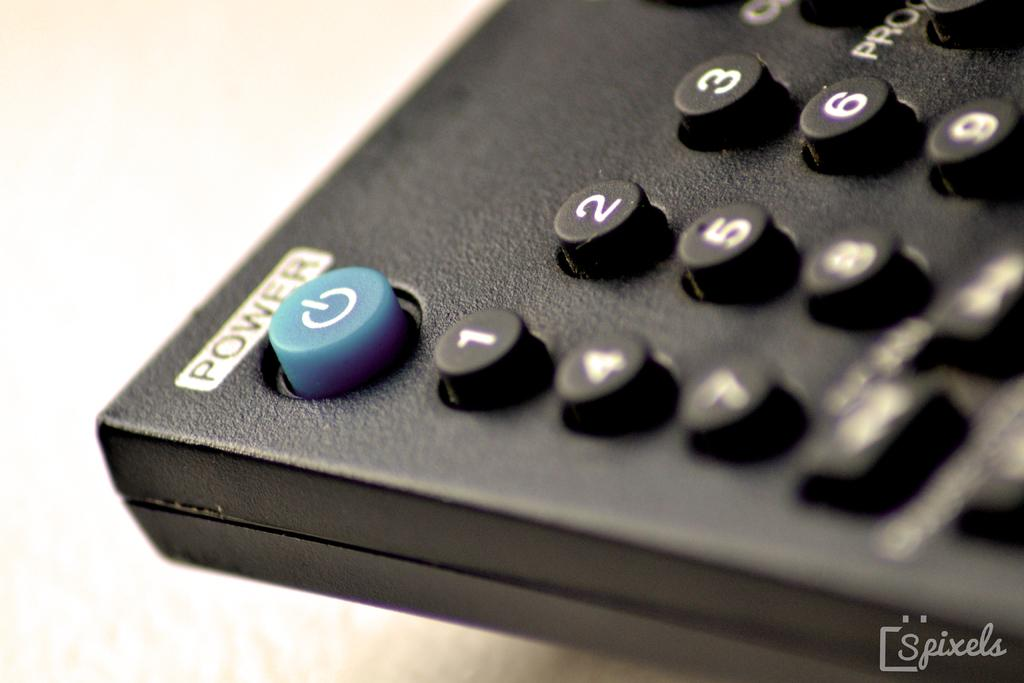<image>
Relay a brief, clear account of the picture shown. A black remote control with the blue Power button visible 